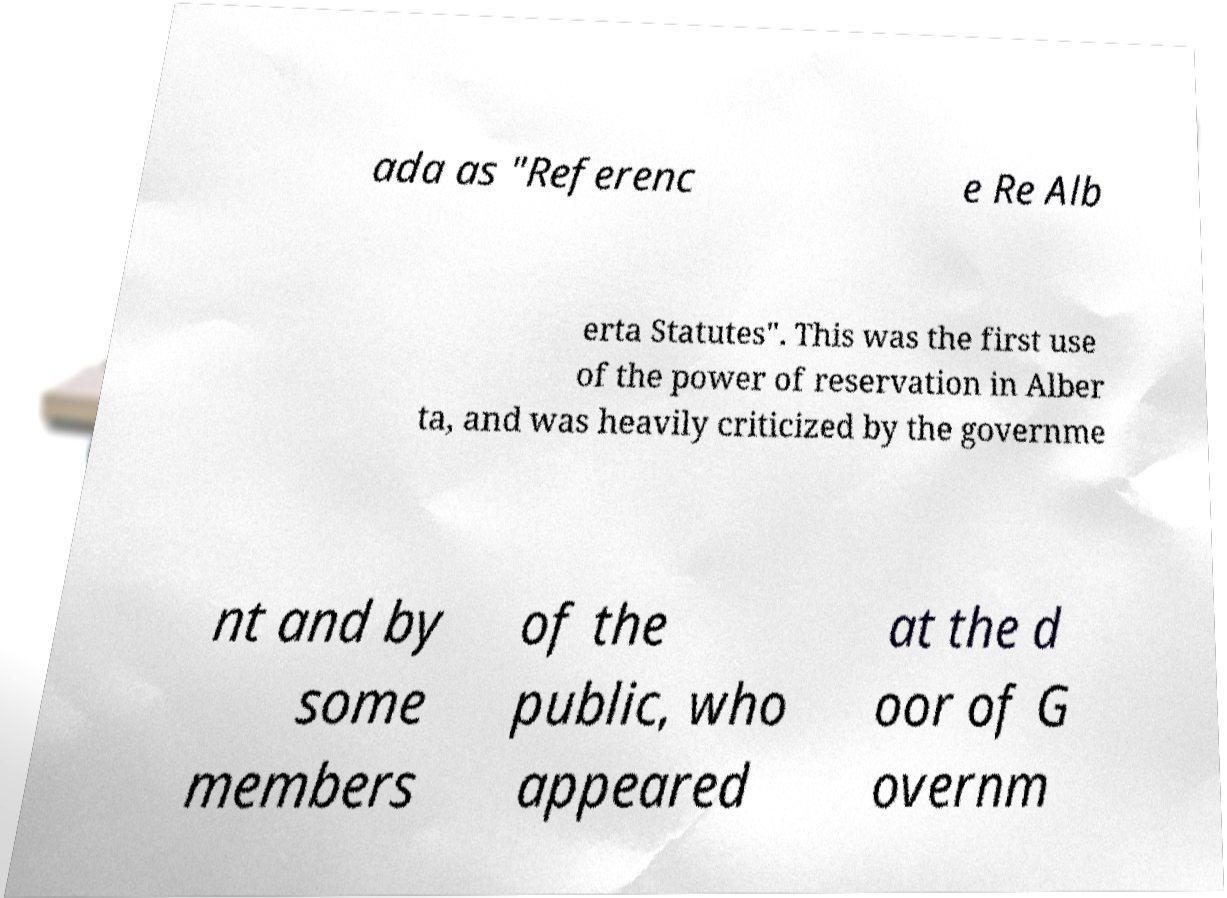Could you extract and type out the text from this image? ada as "Referenc e Re Alb erta Statutes". This was the first use of the power of reservation in Alber ta, and was heavily criticized by the governme nt and by some members of the public, who appeared at the d oor of G overnm 